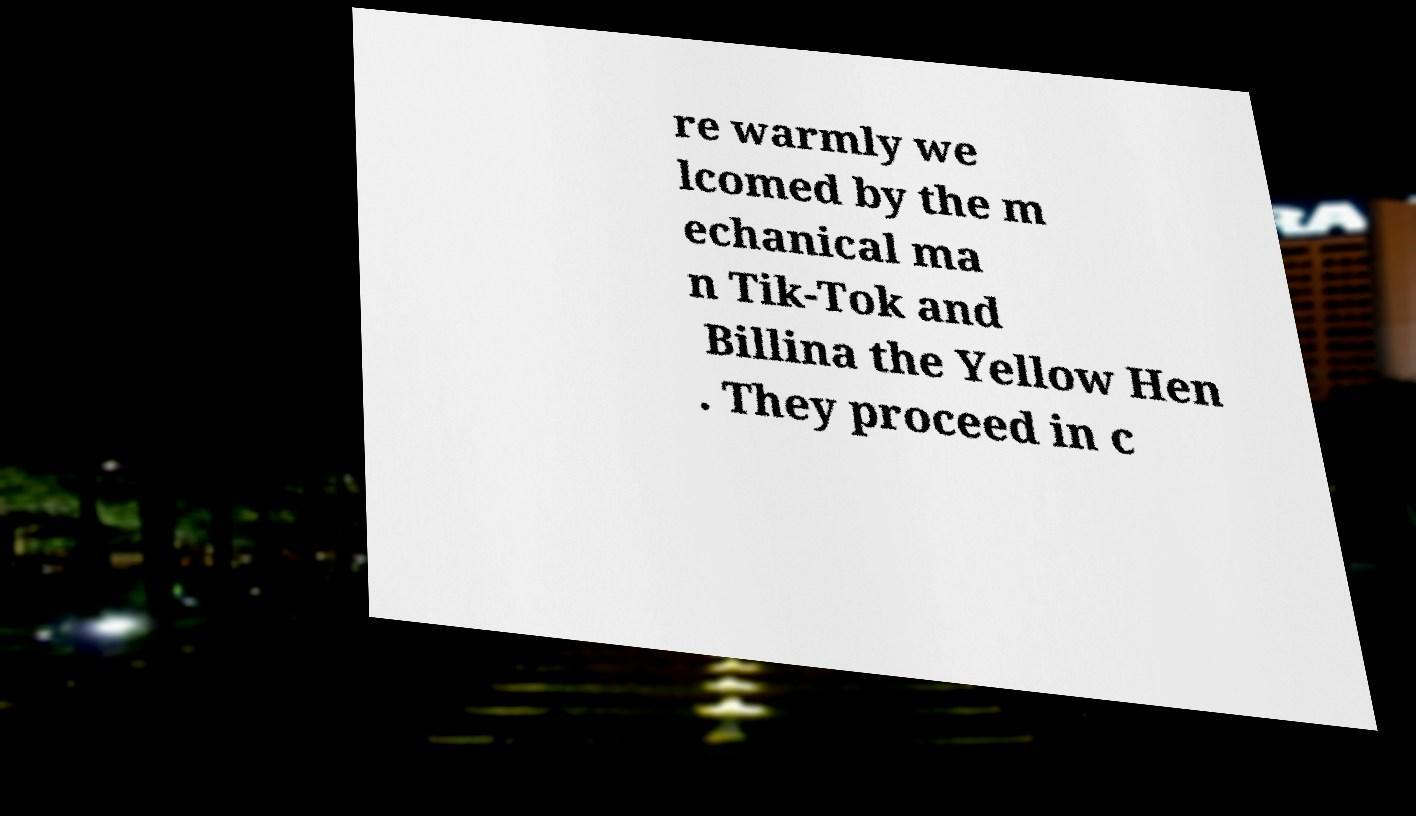I need the written content from this picture converted into text. Can you do that? re warmly we lcomed by the m echanical ma n Tik-Tok and Billina the Yellow Hen . They proceed in c 